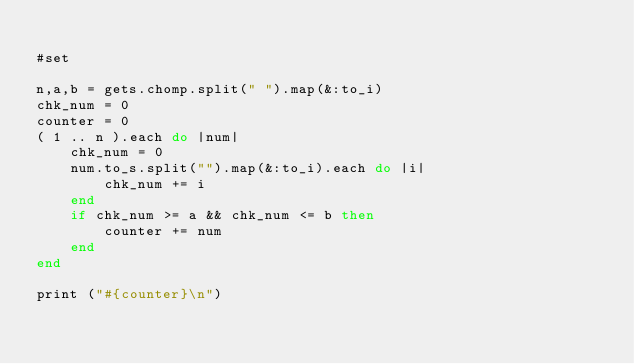Convert code to text. <code><loc_0><loc_0><loc_500><loc_500><_Ruby_>
#set

n,a,b = gets.chomp.split(" ").map(&:to_i)
chk_num = 0
counter = 0
( 1 .. n ).each do |num|
    chk_num = 0
    num.to_s.split("").map(&:to_i).each do |i|
        chk_num += i
    end
    if chk_num >= a && chk_num <= b then
        counter += num
    end
end

print ("#{counter}\n")</code> 